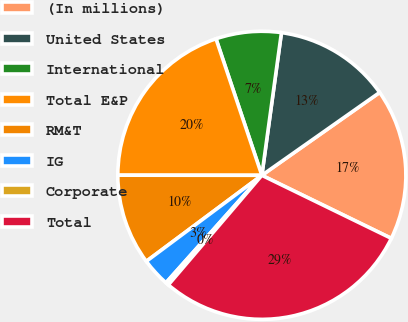Convert chart to OTSL. <chart><loc_0><loc_0><loc_500><loc_500><pie_chart><fcel>(In millions)<fcel>United States<fcel>International<fcel>Total E&P<fcel>RM&T<fcel>IG<fcel>Corporate<fcel>Total<nl><fcel>16.97%<fcel>13.07%<fcel>7.33%<fcel>19.83%<fcel>10.2%<fcel>3.22%<fcel>0.35%<fcel>29.03%<nl></chart> 